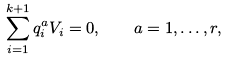<formula> <loc_0><loc_0><loc_500><loc_500>\sum _ { i = 1 } ^ { k + 1 } q _ { i } ^ { a } { V } _ { i } = 0 , \quad a = 1 , \dots , r ,</formula> 